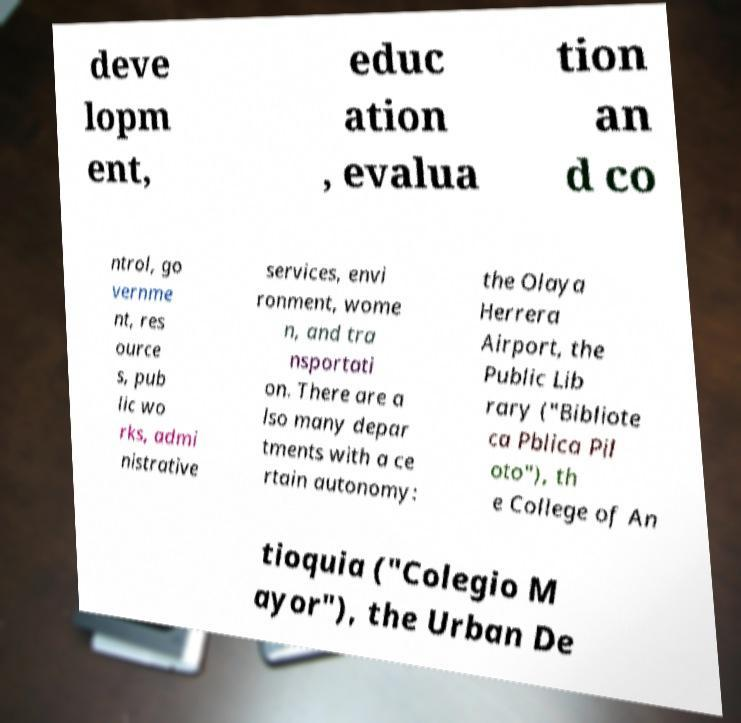Can you accurately transcribe the text from the provided image for me? deve lopm ent, educ ation , evalua tion an d co ntrol, go vernme nt, res ource s, pub lic wo rks, admi nistrative services, envi ronment, wome n, and tra nsportati on. There are a lso many depar tments with a ce rtain autonomy: the Olaya Herrera Airport, the Public Lib rary ("Bibliote ca Pblica Pil oto"), th e College of An tioquia ("Colegio M ayor"), the Urban De 